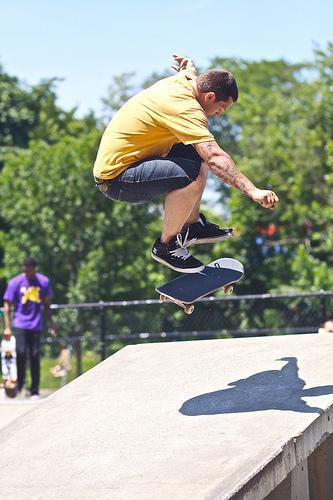How many people are in the picture?
Give a very brief answer. 2. 